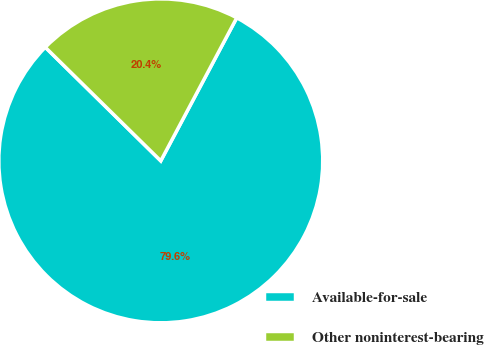Convert chart. <chart><loc_0><loc_0><loc_500><loc_500><pie_chart><fcel>Available-for-sale<fcel>Other noninterest-bearing<nl><fcel>79.6%<fcel>20.4%<nl></chart> 